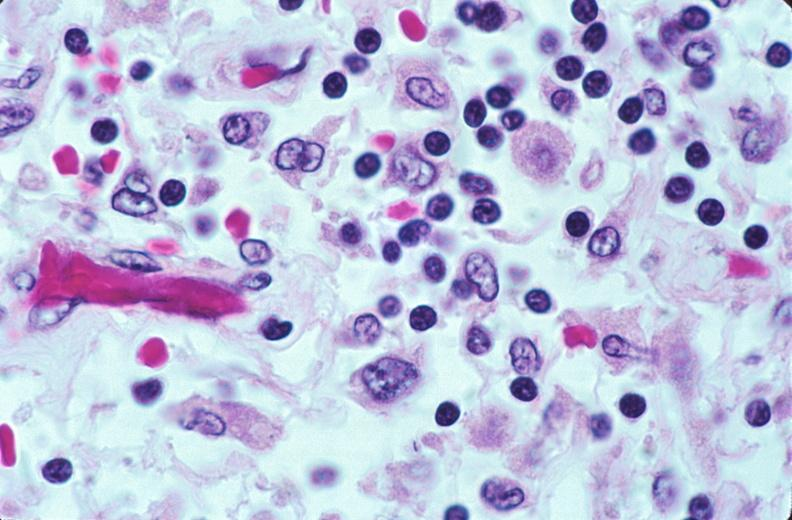what does this image show?
Answer the question using a single word or phrase. Lymph nodes 